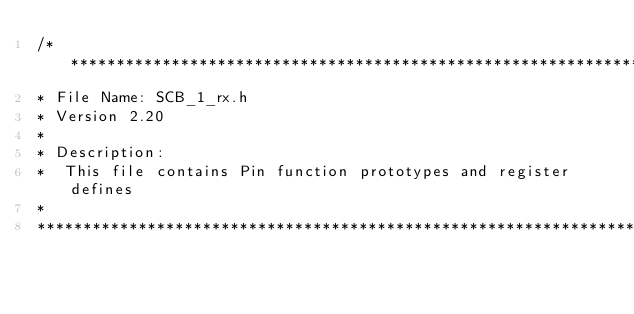<code> <loc_0><loc_0><loc_500><loc_500><_C_>/*******************************************************************************
* File Name: SCB_1_rx.h  
* Version 2.20
*
* Description:
*  This file contains Pin function prototypes and register defines
*
********************************************************************************</code> 